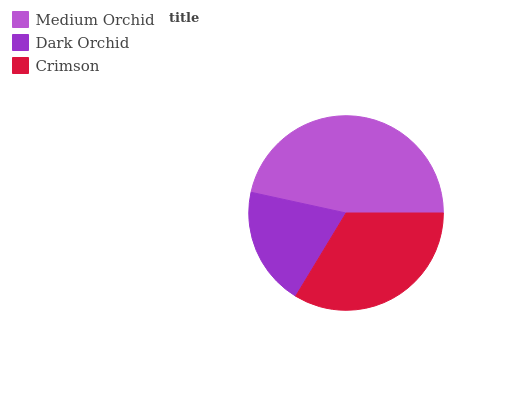Is Dark Orchid the minimum?
Answer yes or no. Yes. Is Medium Orchid the maximum?
Answer yes or no. Yes. Is Crimson the minimum?
Answer yes or no. No. Is Crimson the maximum?
Answer yes or no. No. Is Crimson greater than Dark Orchid?
Answer yes or no. Yes. Is Dark Orchid less than Crimson?
Answer yes or no. Yes. Is Dark Orchid greater than Crimson?
Answer yes or no. No. Is Crimson less than Dark Orchid?
Answer yes or no. No. Is Crimson the high median?
Answer yes or no. Yes. Is Crimson the low median?
Answer yes or no. Yes. Is Dark Orchid the high median?
Answer yes or no. No. Is Dark Orchid the low median?
Answer yes or no. No. 